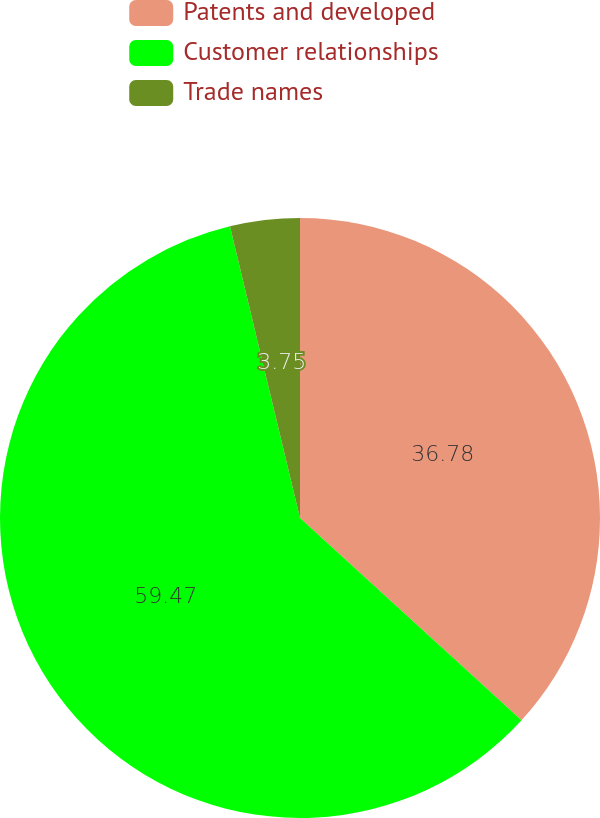Convert chart. <chart><loc_0><loc_0><loc_500><loc_500><pie_chart><fcel>Patents and developed<fcel>Customer relationships<fcel>Trade names<nl><fcel>36.78%<fcel>59.47%<fcel>3.75%<nl></chart> 